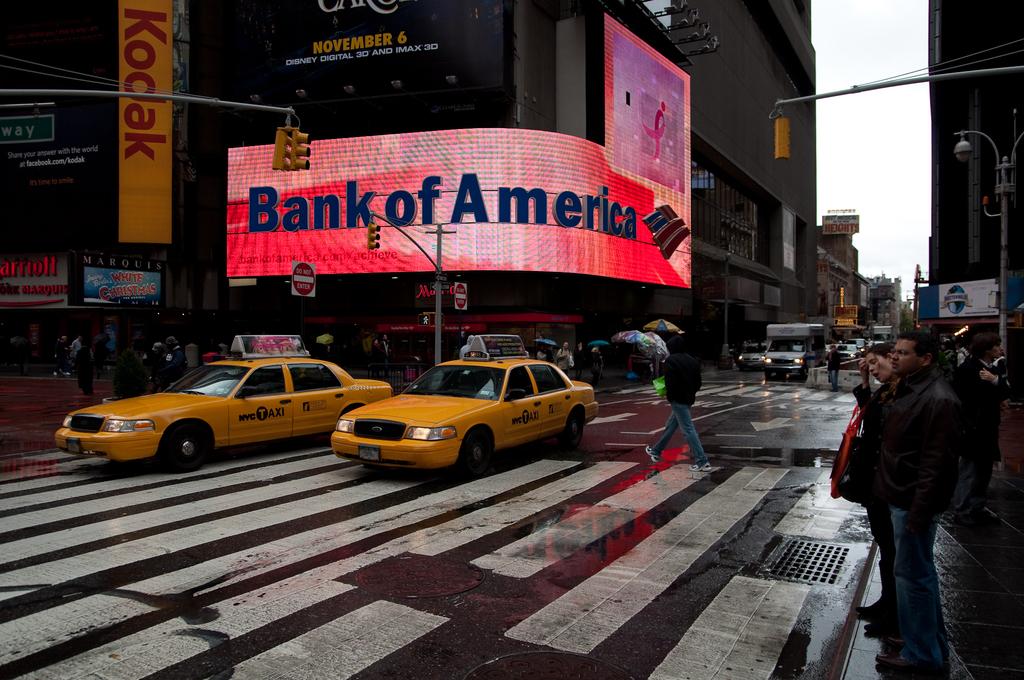Which bank is this?
Your response must be concise. Bank of america. What camera company can be seen advertised?
Provide a short and direct response. Kodak. 